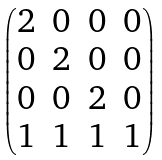Convert formula to latex. <formula><loc_0><loc_0><loc_500><loc_500>\begin{pmatrix} 2 & 0 & 0 & 0 \\ 0 & 2 & 0 & 0 \\ 0 & 0 & 2 & 0 \\ 1 & 1 & 1 & 1 \end{pmatrix}</formula> 